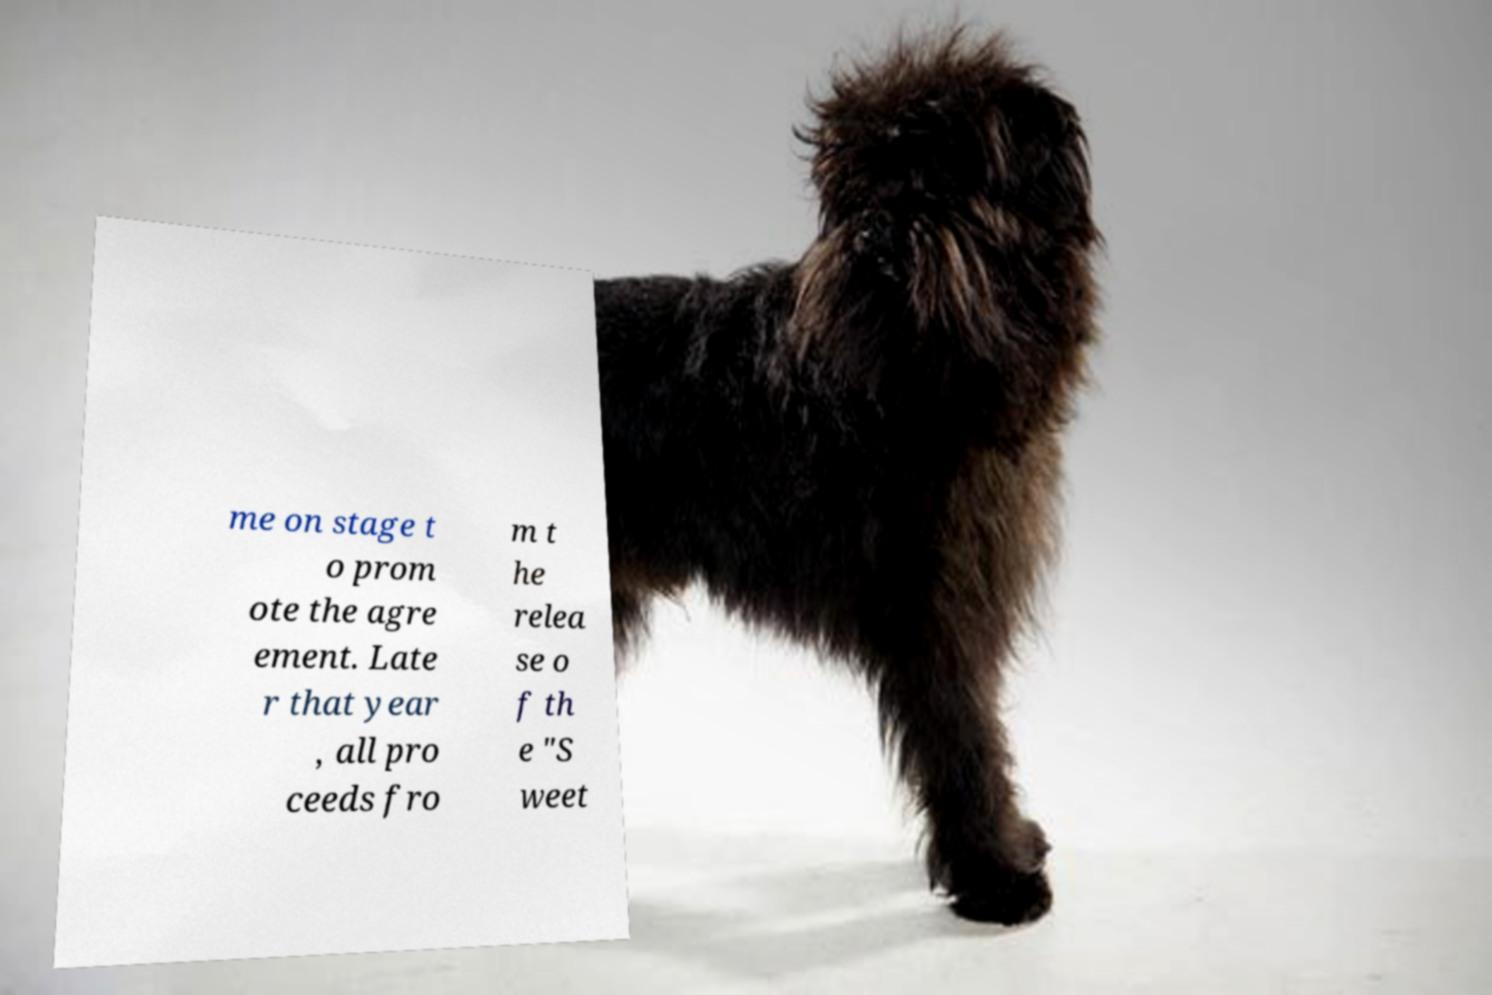Could you extract and type out the text from this image? me on stage t o prom ote the agre ement. Late r that year , all pro ceeds fro m t he relea se o f th e "S weet 